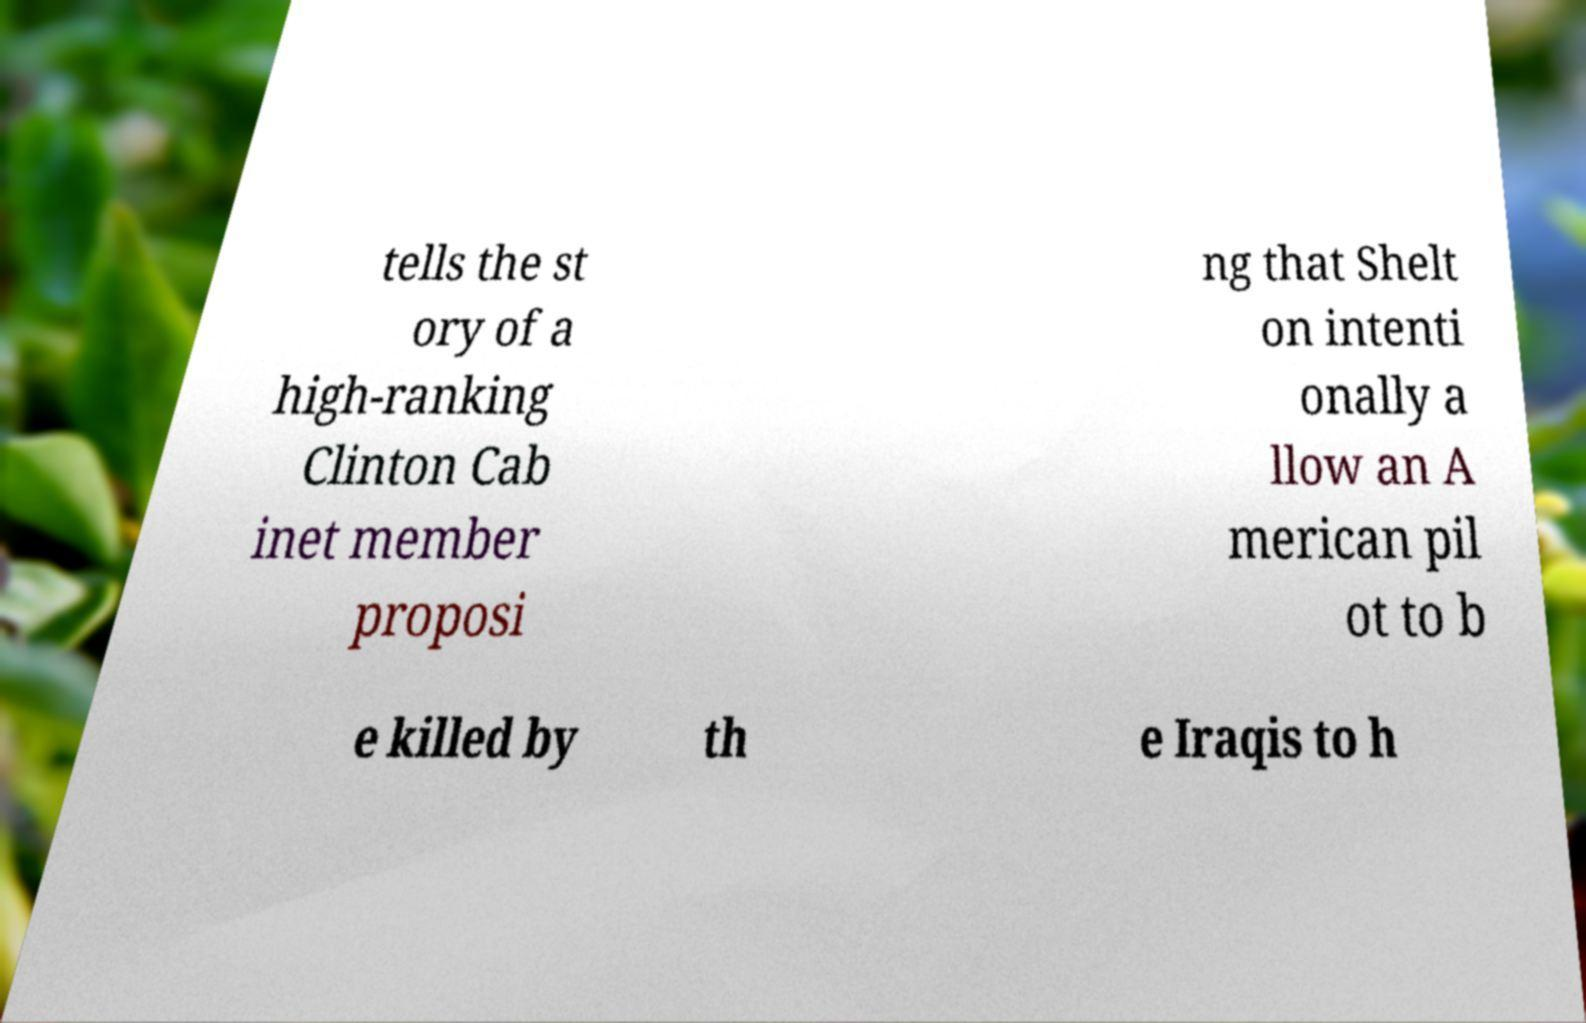Can you read and provide the text displayed in the image?This photo seems to have some interesting text. Can you extract and type it out for me? tells the st ory of a high-ranking Clinton Cab inet member proposi ng that Shelt on intenti onally a llow an A merican pil ot to b e killed by th e Iraqis to h 